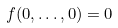Convert formula to latex. <formula><loc_0><loc_0><loc_500><loc_500>f ( 0 , \dots , 0 ) = 0</formula> 